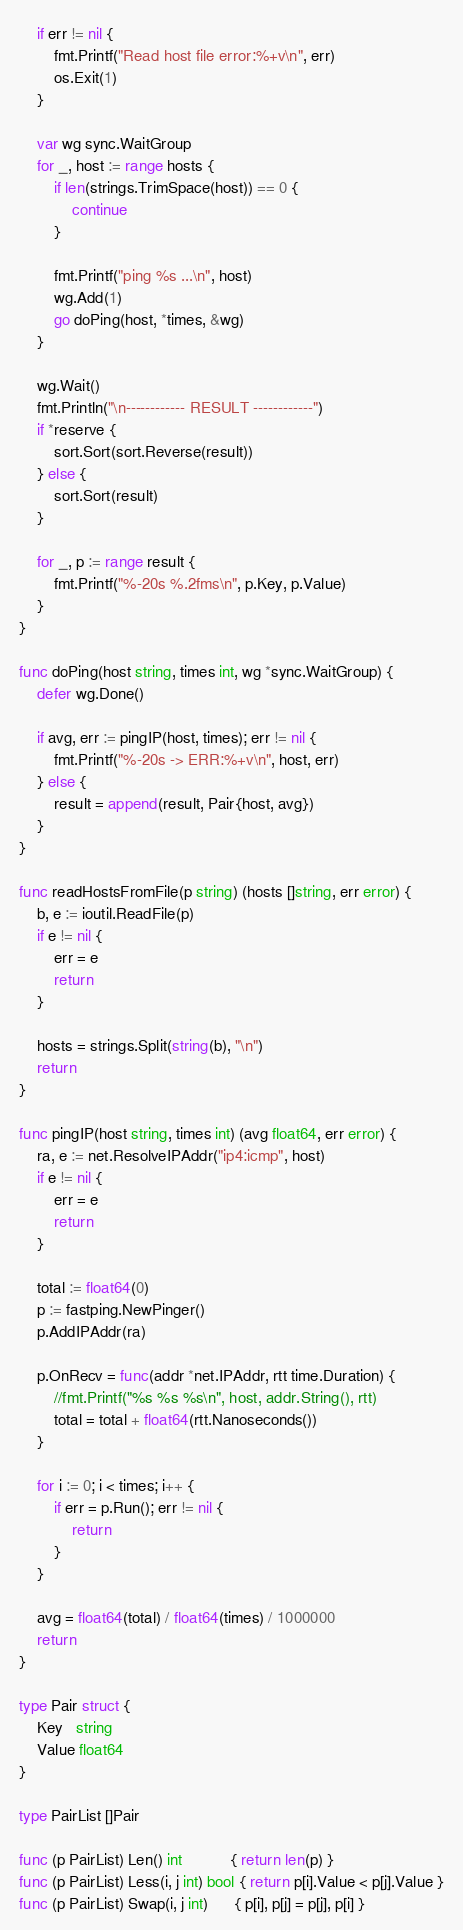Convert code to text. <code><loc_0><loc_0><loc_500><loc_500><_Go_>	if err != nil {
		fmt.Printf("Read host file error:%+v\n", err)
		os.Exit(1)
	}

	var wg sync.WaitGroup
	for _, host := range hosts {
		if len(strings.TrimSpace(host)) == 0 {
			continue
		}

		fmt.Printf("ping %s ...\n", host)
		wg.Add(1)
		go doPing(host, *times, &wg)
	}

	wg.Wait()
	fmt.Println("\n------------ RESULT ------------")
	if *reserve {
		sort.Sort(sort.Reverse(result))
	} else {
		sort.Sort(result)
	}

	for _, p := range result {
		fmt.Printf("%-20s %.2fms\n", p.Key, p.Value)
	}
}

func doPing(host string, times int, wg *sync.WaitGroup) {
	defer wg.Done()

	if avg, err := pingIP(host, times); err != nil {
		fmt.Printf("%-20s -> ERR:%+v\n", host, err)
	} else {
		result = append(result, Pair{host, avg})
	}
}

func readHostsFromFile(p string) (hosts []string, err error) {
	b, e := ioutil.ReadFile(p)
	if e != nil {
		err = e
		return
	}

	hosts = strings.Split(string(b), "\n")
	return
}

func pingIP(host string, times int) (avg float64, err error) {
	ra, e := net.ResolveIPAddr("ip4:icmp", host)
	if e != nil {
		err = e
		return
	}

	total := float64(0)
	p := fastping.NewPinger()
	p.AddIPAddr(ra)

	p.OnRecv = func(addr *net.IPAddr, rtt time.Duration) {
		//fmt.Printf("%s %s %s\n", host, addr.String(), rtt)
		total = total + float64(rtt.Nanoseconds())
	}

	for i := 0; i < times; i++ {
		if err = p.Run(); err != nil {
			return
		}
	}

	avg = float64(total) / float64(times) / 1000000
	return
}

type Pair struct {
	Key   string
	Value float64
}

type PairList []Pair

func (p PairList) Len() int           { return len(p) }
func (p PairList) Less(i, j int) bool { return p[i].Value < p[j].Value }
func (p PairList) Swap(i, j int)      { p[i], p[j] = p[j], p[i] }
</code> 